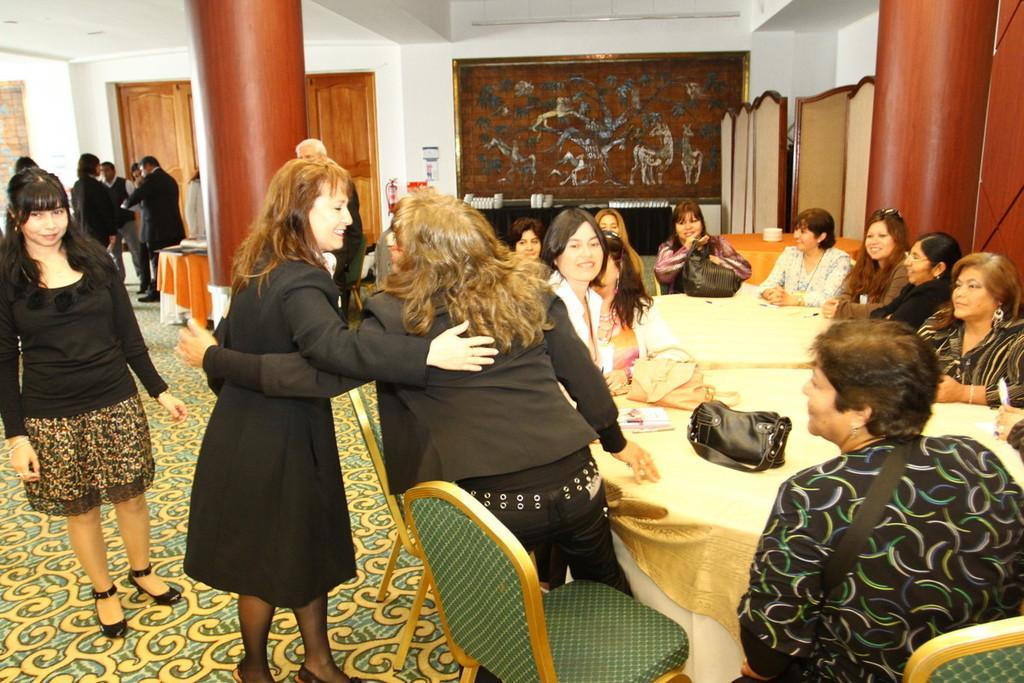In one or two sentences, can you explain what this image depicts? In this picture there are group of people those who are sitting around the table and there is a door at the right side of the image and there is a portrait at the center of the image, there are two ladies those who are standing at the center of the image they are hugging each other. 